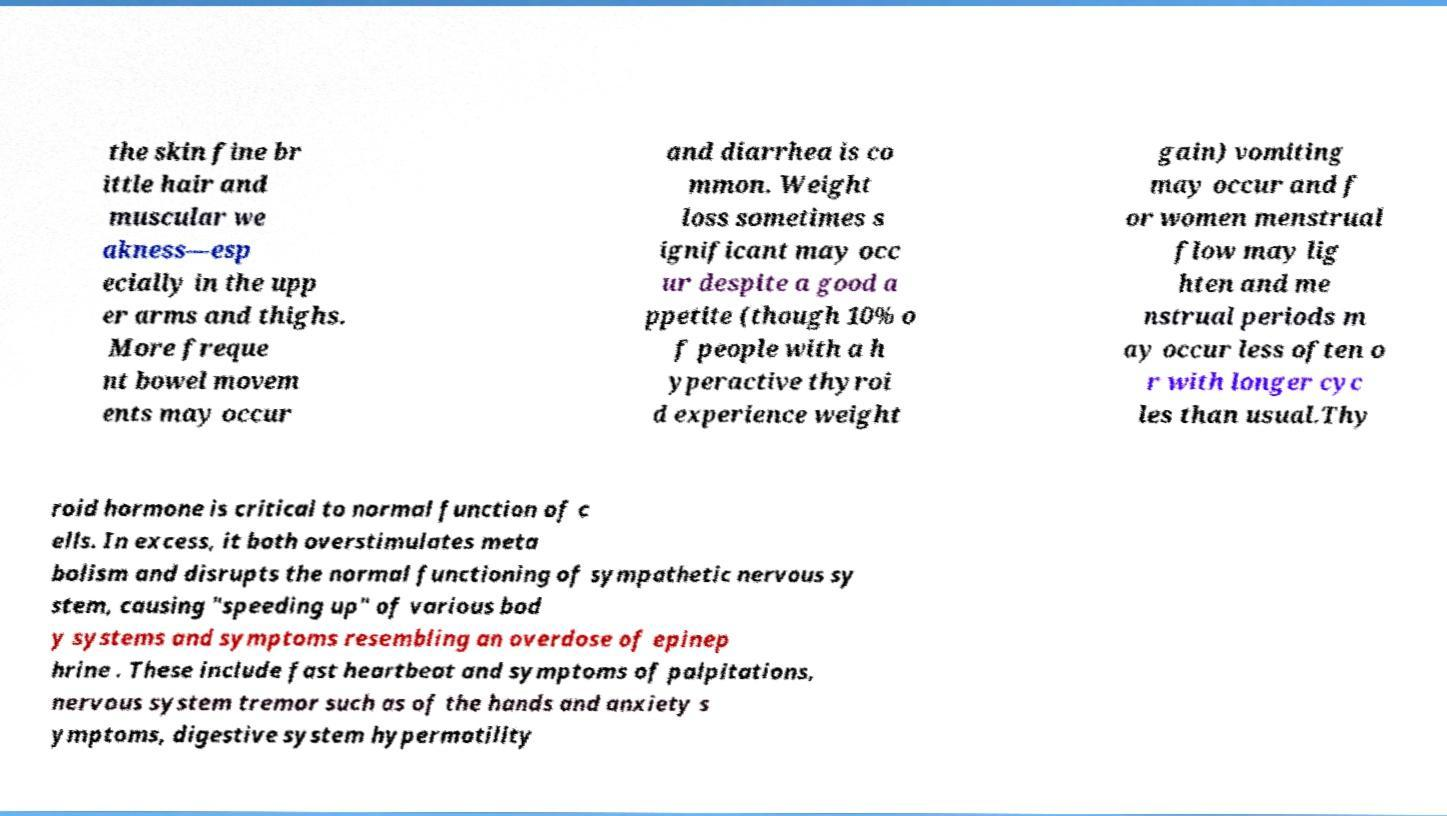Please read and relay the text visible in this image. What does it say? the skin fine br ittle hair and muscular we akness—esp ecially in the upp er arms and thighs. More freque nt bowel movem ents may occur and diarrhea is co mmon. Weight loss sometimes s ignificant may occ ur despite a good a ppetite (though 10% o f people with a h yperactive thyroi d experience weight gain) vomiting may occur and f or women menstrual flow may lig hten and me nstrual periods m ay occur less often o r with longer cyc les than usual.Thy roid hormone is critical to normal function of c ells. In excess, it both overstimulates meta bolism and disrupts the normal functioning of sympathetic nervous sy stem, causing "speeding up" of various bod y systems and symptoms resembling an overdose of epinep hrine . These include fast heartbeat and symptoms of palpitations, nervous system tremor such as of the hands and anxiety s ymptoms, digestive system hypermotility 